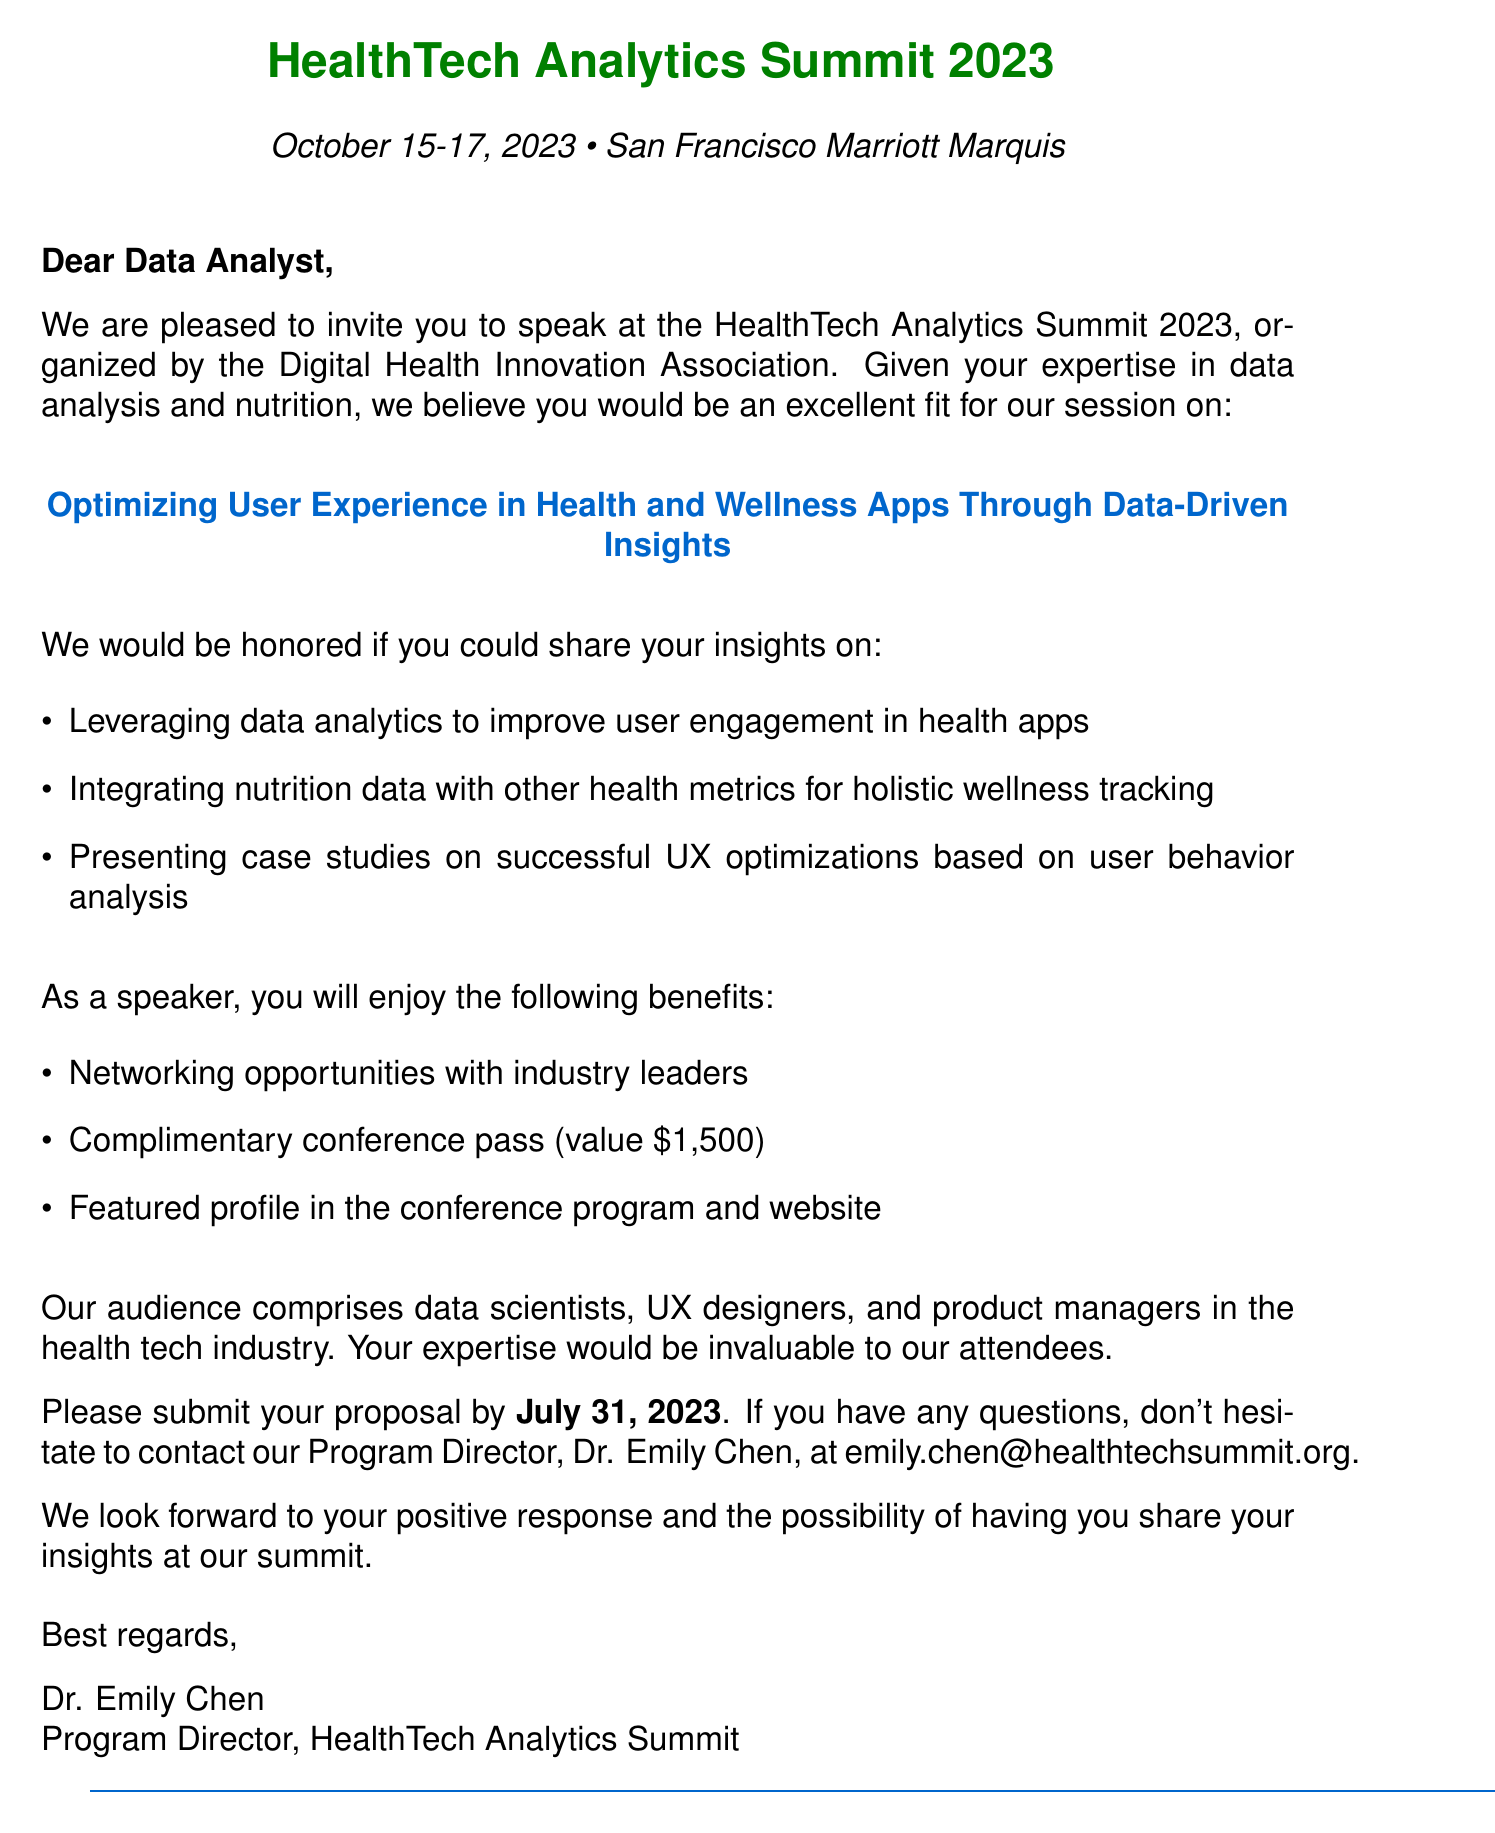What are the dates of the conference? The dates of the conference are explicitly mentioned in the document.
Answer: October 15-17, 2023 Who is organizing the event? The organizer is specified in the conference details section of the document.
Answer: Digital Health Innovation Association What is the location of the summit? The document states the location of the conference.
Answer: San Francisco Marriott Marquis What is the submission deadline for proposals? The submission deadline is clearly indicated in the document.
Answer: July 31, 2023 What are the speaker benefits listed? The benefits are outlined in an itemized list in the document, allowing for easy retrieval.
Answer: Networking opportunities with industry leaders, complimentary conference pass (value $1,500), featured profile in the conference program and website What session topic will the speaker address? The session topic is highlighted in the invitation, outlining the main focus area.
Answer: Optimizing User Experience in Health and Wellness Apps Through Data-Driven Insights What audience is the conference aimed at? The intended audience is specifically mentioned in the document.
Answer: Data scientists, UX designers, and product managers in the health tech industry Who should be contacted for questions? The contact person is clearly named toward the end of the document.
Answer: Dr. Emily Chen What is one case study focus for the speaker's presentation? The document lists a key point for discussion related to case studies.
Answer: Successful UX optimizations based on user behavior analysis 